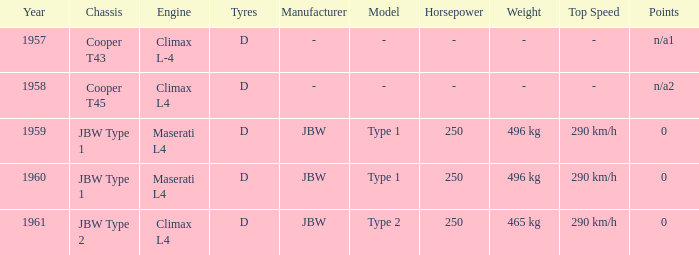What is the tyres for the JBW type 2 chassis? D. 